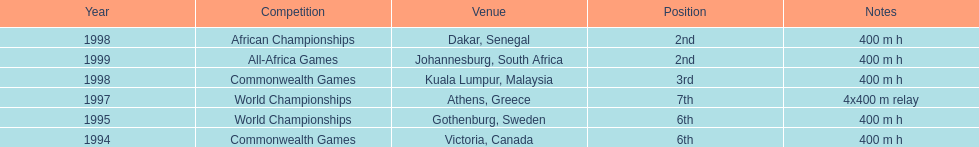Could you parse the entire table? {'header': ['Year', 'Competition', 'Venue', 'Position', 'Notes'], 'rows': [['1998', 'African Championships', 'Dakar, Senegal', '2nd', '400 m h'], ['1999', 'All-Africa Games', 'Johannesburg, South Africa', '2nd', '400 m h'], ['1998', 'Commonwealth Games', 'Kuala Lumpur, Malaysia', '3rd', '400 m h'], ['1997', 'World Championships', 'Athens, Greece', '7th', '4x400 m relay'], ['1995', 'World Championships', 'Gothenburg, Sweden', '6th', '400 m h'], ['1994', 'Commonwealth Games', 'Victoria, Canada', '6th', '400 m h']]} Where was the next venue after athens, greece? Kuala Lumpur, Malaysia. 